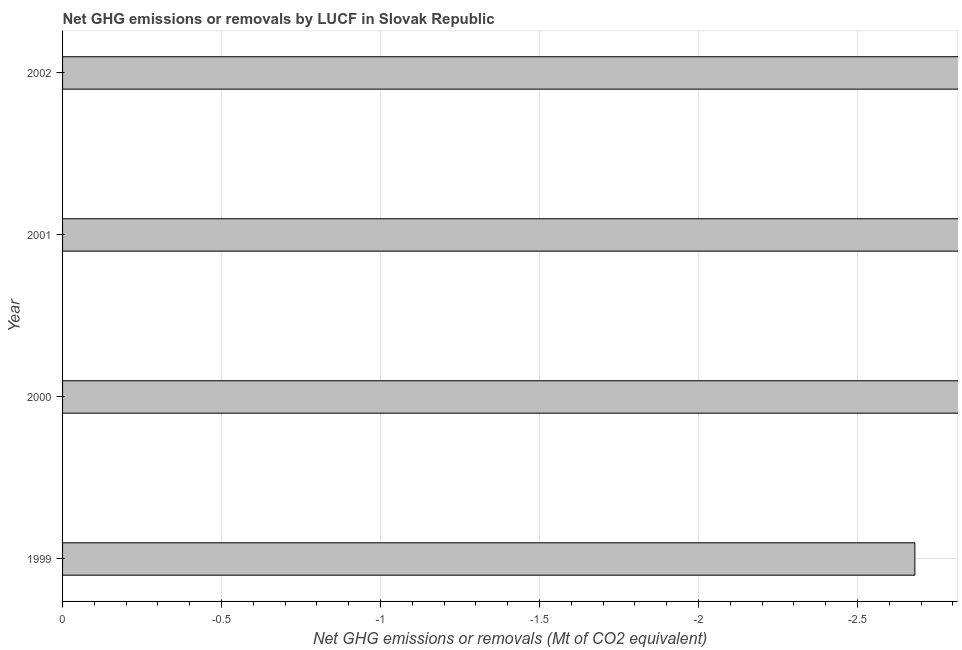What is the title of the graph?
Make the answer very short. Net GHG emissions or removals by LUCF in Slovak Republic. What is the label or title of the X-axis?
Your answer should be very brief. Net GHG emissions or removals (Mt of CO2 equivalent). What is the label or title of the Y-axis?
Keep it short and to the point. Year. What is the ghg net emissions or removals in 2000?
Ensure brevity in your answer.  0. Across all years, what is the minimum ghg net emissions or removals?
Ensure brevity in your answer.  0. What is the average ghg net emissions or removals per year?
Your response must be concise. 0. In how many years, is the ghg net emissions or removals greater than the average ghg net emissions or removals taken over all years?
Provide a short and direct response. 0. How many years are there in the graph?
Your answer should be compact. 4. What is the Net GHG emissions or removals (Mt of CO2 equivalent) of 2000?
Your answer should be very brief. 0. 